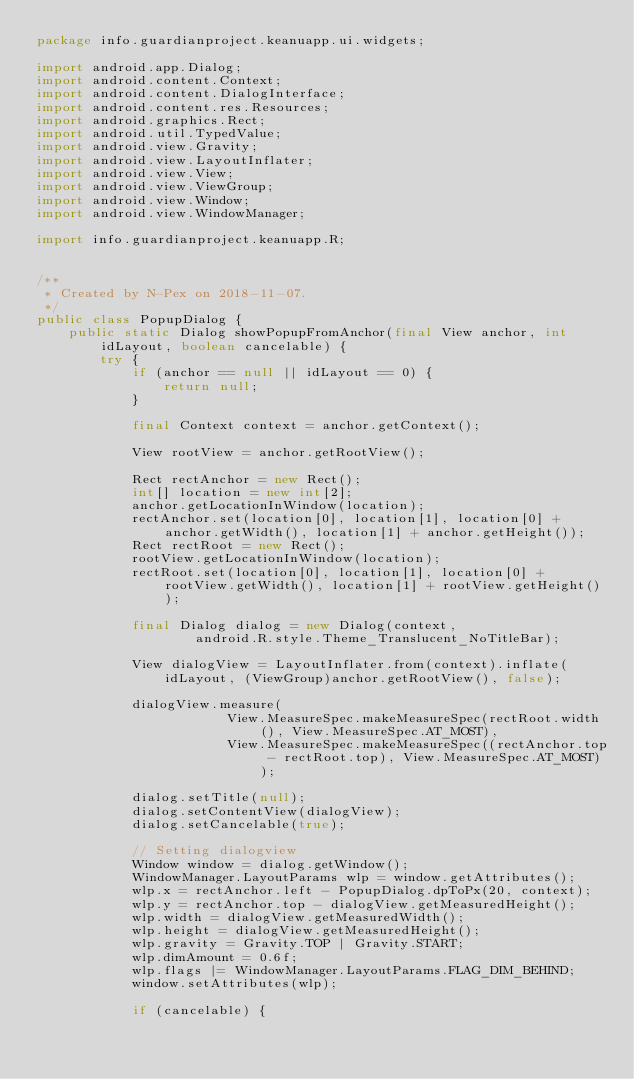<code> <loc_0><loc_0><loc_500><loc_500><_Java_>package info.guardianproject.keanuapp.ui.widgets;

import android.app.Dialog;
import android.content.Context;
import android.content.DialogInterface;
import android.content.res.Resources;
import android.graphics.Rect;
import android.util.TypedValue;
import android.view.Gravity;
import android.view.LayoutInflater;
import android.view.View;
import android.view.ViewGroup;
import android.view.Window;
import android.view.WindowManager;

import info.guardianproject.keanuapp.R;


/**
 * Created by N-Pex on 2018-11-07.
 */
public class PopupDialog {
    public static Dialog showPopupFromAnchor(final View anchor, int idLayout, boolean cancelable) {
        try {
            if (anchor == null || idLayout == 0) {
                return null;
            }

            final Context context = anchor.getContext();

            View rootView = anchor.getRootView();

            Rect rectAnchor = new Rect();
            int[] location = new int[2];
            anchor.getLocationInWindow(location);
            rectAnchor.set(location[0], location[1], location[0] + anchor.getWidth(), location[1] + anchor.getHeight());
            Rect rectRoot = new Rect();
            rootView.getLocationInWindow(location);
            rectRoot.set(location[0], location[1], location[0] + rootView.getWidth(), location[1] + rootView.getHeight());

            final Dialog dialog = new Dialog(context,
                    android.R.style.Theme_Translucent_NoTitleBar);

            View dialogView = LayoutInflater.from(context).inflate(idLayout, (ViewGroup)anchor.getRootView(), false);

            dialogView.measure(
                        View.MeasureSpec.makeMeasureSpec(rectRoot.width(), View.MeasureSpec.AT_MOST),
                        View.MeasureSpec.makeMeasureSpec((rectAnchor.top - rectRoot.top), View.MeasureSpec.AT_MOST));

            dialog.setTitle(null);
            dialog.setContentView(dialogView);
            dialog.setCancelable(true);

            // Setting dialogview
            Window window = dialog.getWindow();
            WindowManager.LayoutParams wlp = window.getAttributes();
            wlp.x = rectAnchor.left - PopupDialog.dpToPx(20, context);
            wlp.y = rectAnchor.top - dialogView.getMeasuredHeight();
            wlp.width = dialogView.getMeasuredWidth();
            wlp.height = dialogView.getMeasuredHeight();
            wlp.gravity = Gravity.TOP | Gravity.START;
            wlp.dimAmount = 0.6f;
            wlp.flags |= WindowManager.LayoutParams.FLAG_DIM_BEHIND;
            window.setAttributes(wlp);

            if (cancelable) {</code> 